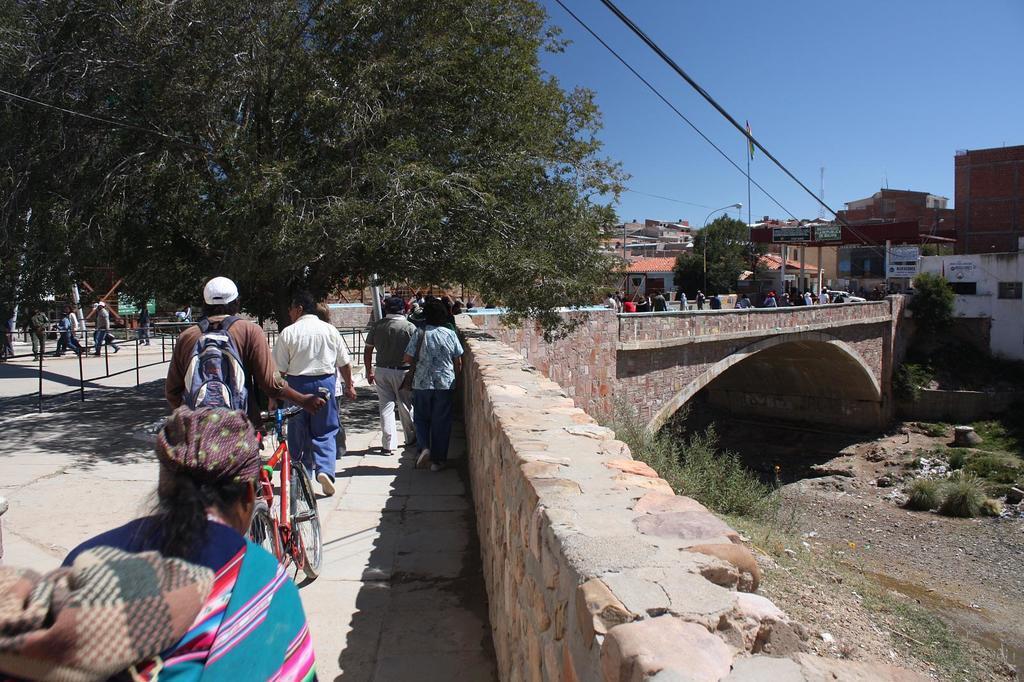Can you describe this image briefly? In this picture we can see a group of people and a bicycle on the ground and in the background we can see a bridge, vehicle, buildings, trees, poles, sky and some objects. 